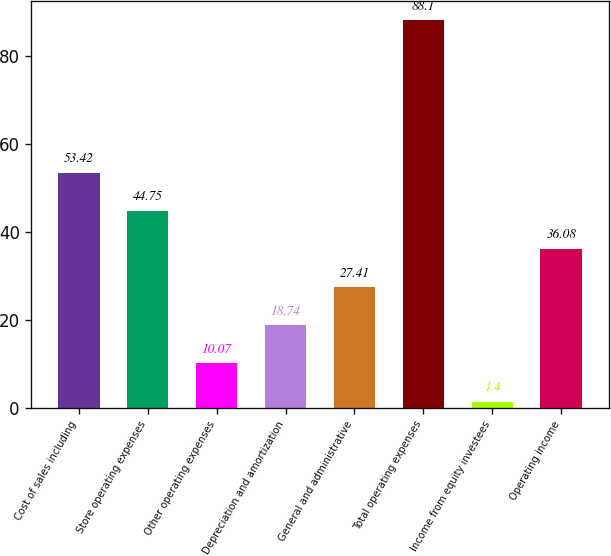Convert chart. <chart><loc_0><loc_0><loc_500><loc_500><bar_chart><fcel>Cost of sales including<fcel>Store operating expenses<fcel>Other operating expenses<fcel>Depreciation and amortization<fcel>General and administrative<fcel>Total operating expenses<fcel>Income from equity investees<fcel>Operating income<nl><fcel>53.42<fcel>44.75<fcel>10.07<fcel>18.74<fcel>27.41<fcel>88.1<fcel>1.4<fcel>36.08<nl></chart> 